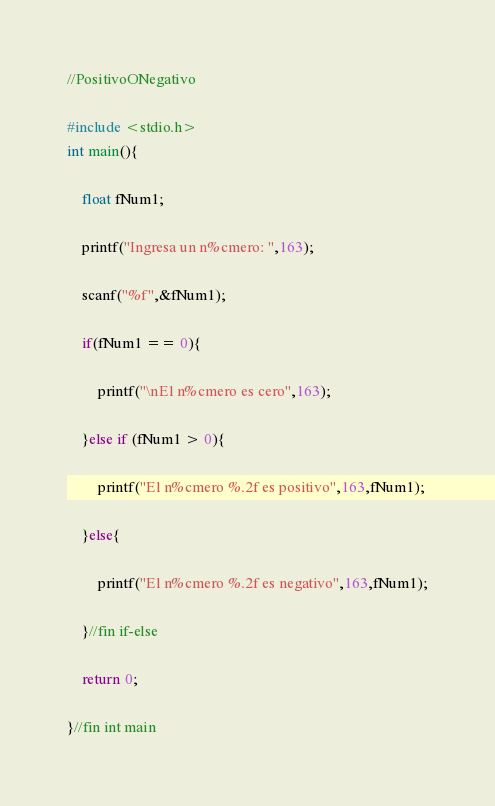<code> <loc_0><loc_0><loc_500><loc_500><_C_>//PositivoONegativo

#include <stdio.h>
int main(){
	
	float fNum1;
	
	printf("Ingresa un n%cmero: ",163);
	
	scanf("%f",&fNum1);
	
	if(fNum1 == 0){
		
		printf("\nEl n%cmero es cero",163);
		
	}else if (fNum1 > 0){
		
		printf("El n%cmero %.2f es positivo",163,fNum1);
		
	}else{
		
		printf("El n%cmero %.2f es negativo",163,fNum1);
		
	}//fin if-else
	
	return 0;
	
}//fin int main 
</code> 